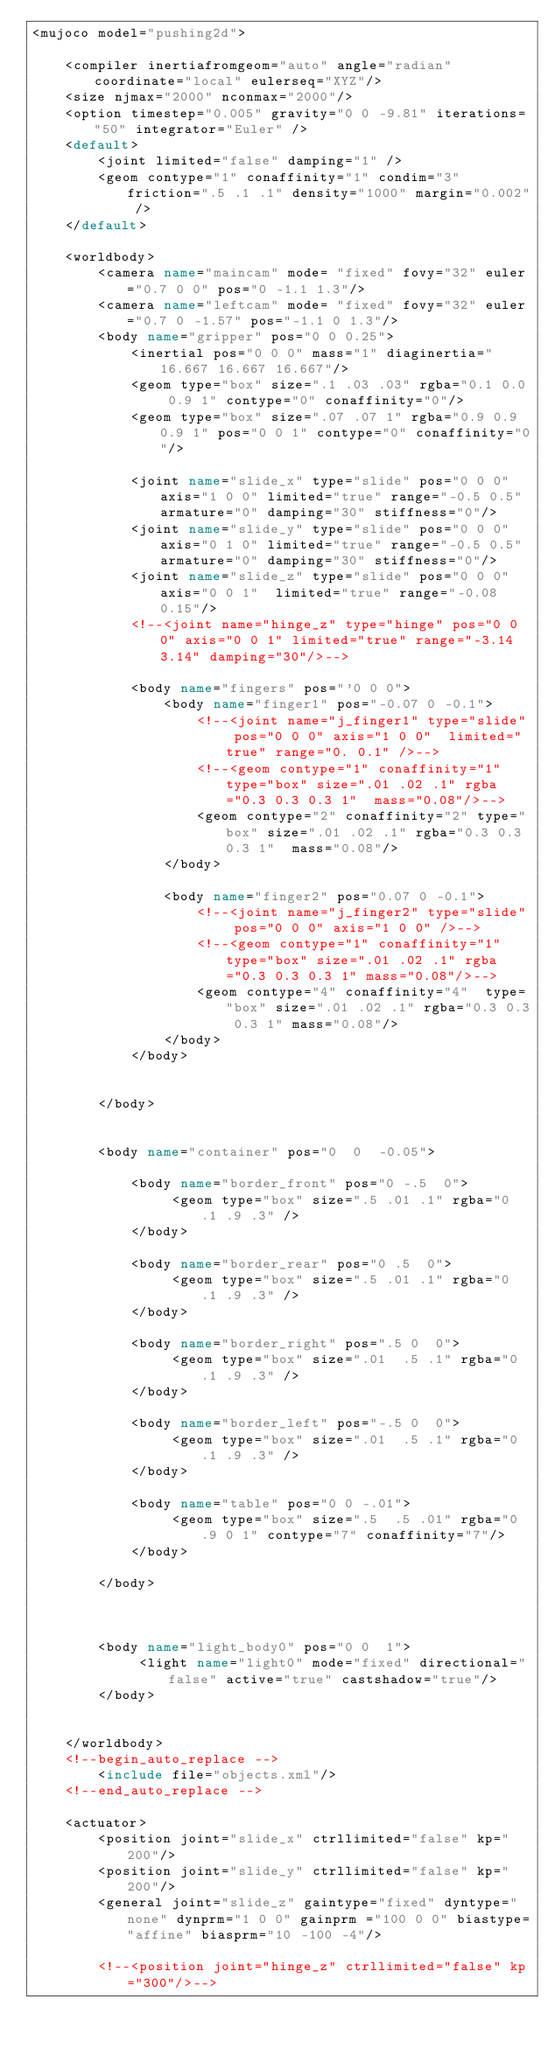<code> <loc_0><loc_0><loc_500><loc_500><_XML_><mujoco model="pushing2d">

    <compiler inertiafromgeom="auto" angle="radian" coordinate="local" eulerseq="XYZ"/>
    <size njmax="2000" nconmax="2000"/>
    <option timestep="0.005" gravity="0 0 -9.81" iterations="50" integrator="Euler" />
    <default>
        <joint limited="false" damping="1" />
        <geom contype="1" conaffinity="1" condim="3" friction=".5 .1 .1" density="1000" margin="0.002" />
    </default>

    <worldbody>
        <camera name="maincam" mode= "fixed" fovy="32" euler="0.7 0 0" pos="0 -1.1 1.3"/>
        <camera name="leftcam" mode= "fixed" fovy="32" euler="0.7 0 -1.57" pos="-1.1 0 1.3"/>
        <body name="gripper" pos="0 0 0.25">
            <inertial pos="0 0 0" mass="1" diaginertia="16.667 16.667 16.667"/>
            <geom type="box" size=".1 .03 .03" rgba="0.1 0.0 0.9 1" contype="0" conaffinity="0"/>
            <geom type="box" size=".07 .07 1" rgba="0.9 0.9 0.9 1" pos="0 0 1" contype="0" conaffinity="0"/>

            <joint name="slide_x" type="slide" pos="0 0 0" axis="1 0 0" limited="true" range="-0.5 0.5" armature="0" damping="30" stiffness="0"/>
            <joint name="slide_y" type="slide" pos="0 0 0" axis="0 1 0" limited="true" range="-0.5 0.5" armature="0" damping="30" stiffness="0"/>
            <joint name="slide_z" type="slide" pos="0 0 0" axis="0 0 1"  limited="true" range="-0.08 0.15"/>
            <!--<joint name="hinge_z" type="hinge" pos="0 0 0" axis="0 0 1" limited="true" range="-3.14 3.14" damping="30"/>-->

            <body name="fingers" pos="'0 0 0">
                <body name="finger1" pos="-0.07 0 -0.1">
                    <!--<joint name="j_finger1" type="slide" pos="0 0 0" axis="1 0 0"  limited="true" range="0. 0.1" />-->
                    <!--<geom contype="1" conaffinity="1" type="box" size=".01 .02 .1" rgba="0.3 0.3 0.3 1"  mass="0.08"/>-->
                    <geom contype="2" conaffinity="2" type="box" size=".01 .02 .1" rgba="0.3 0.3 0.3 1"  mass="0.08"/>
                </body>

                <body name="finger2" pos="0.07 0 -0.1">
                    <!--<joint name="j_finger2" type="slide" pos="0 0 0" axis="1 0 0" />-->
                    <!--<geom contype="1" conaffinity="1"  type="box" size=".01 .02 .1" rgba="0.3 0.3 0.3 1" mass="0.08"/>-->
                    <geom contype="4" conaffinity="4"  type="box" size=".01 .02 .1" rgba="0.3 0.3 0.3 1" mass="0.08"/>
                </body>
            </body>


        </body>


        <body name="container" pos="0  0  -0.05">

            <body name="border_front" pos="0 -.5  0">
                 <geom type="box" size=".5 .01 .1" rgba="0 .1 .9 .3" />
            </body>

            <body name="border_rear" pos="0 .5  0">
                 <geom type="box" size=".5 .01 .1" rgba="0 .1 .9 .3" />
            </body>

            <body name="border_right" pos=".5 0  0">
                 <geom type="box" size=".01  .5 .1" rgba="0 .1 .9 .3" />
            </body>

            <body name="border_left" pos="-.5 0  0">
                 <geom type="box" size=".01  .5 .1" rgba="0 .1 .9 .3" />
            </body>

            <body name="table" pos="0 0 -.01">
                 <geom type="box" size=".5  .5 .01" rgba="0 .9 0 1" contype="7" conaffinity="7"/>
            </body>

        </body>



        <body name="light_body0" pos="0 0  1">
             <light name="light0" mode="fixed" directional="false" active="true" castshadow="true"/>
        </body>


    </worldbody>
    <!--begin_auto_replace -->
        <include file="objects.xml"/>
    <!--end_auto_replace -->

    <actuator>
        <position joint="slide_x" ctrllimited="false" kp="200"/>
        <position joint="slide_y" ctrllimited="false" kp="200"/>
        <general joint="slide_z" gaintype="fixed" dyntype="none" dynprm="1 0 0" gainprm ="100 0 0" biastype="affine" biasprm="10 -100 -4"/>

        <!--<position joint="hinge_z" ctrllimited="false" kp="300"/>--></code> 